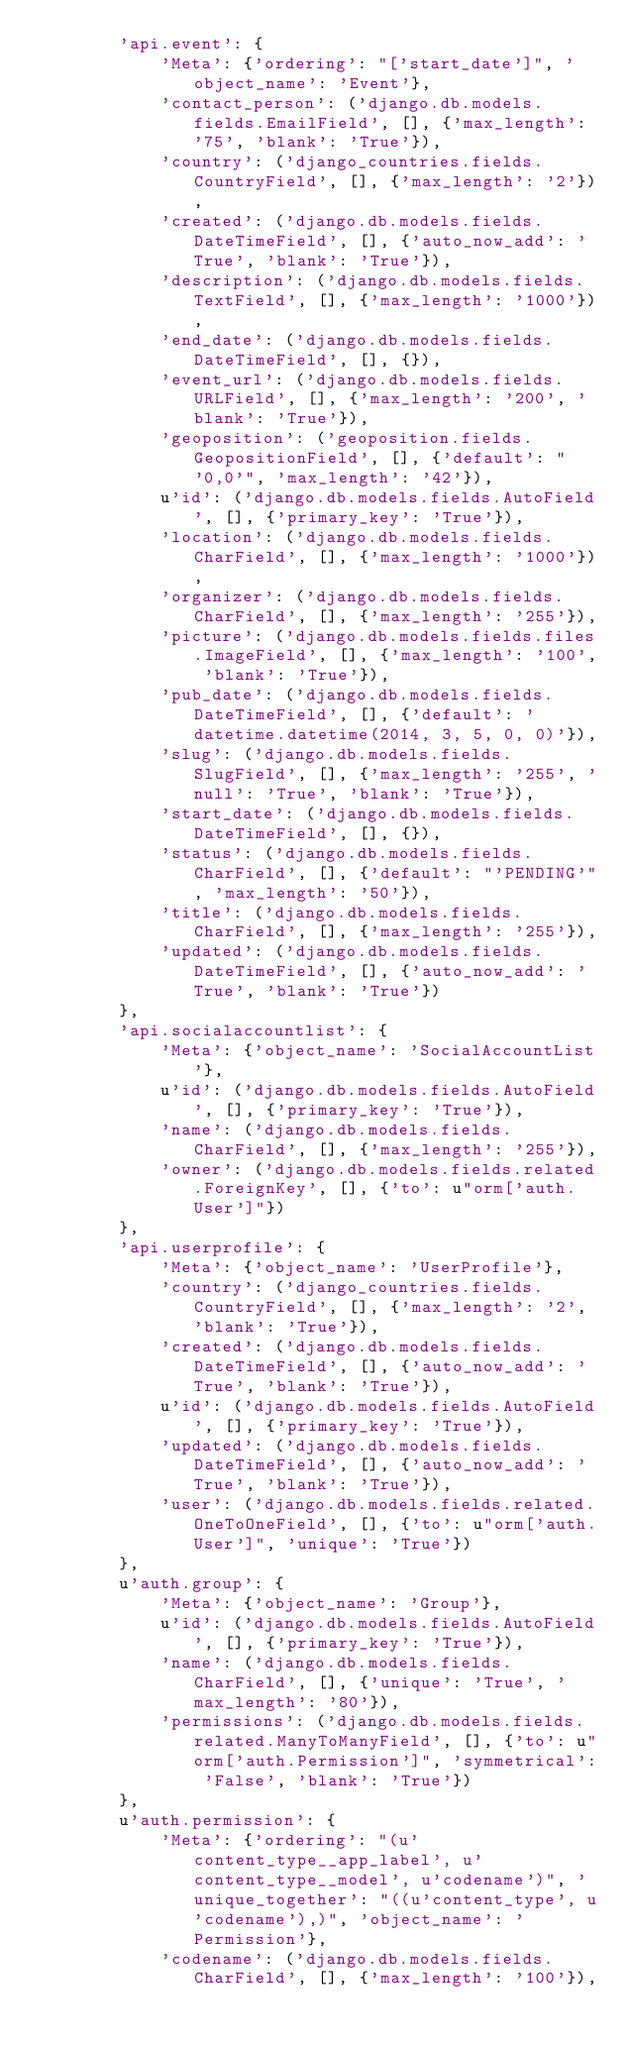<code> <loc_0><loc_0><loc_500><loc_500><_Python_>        'api.event': {
            'Meta': {'ordering': "['start_date']", 'object_name': 'Event'},
            'contact_person': ('django.db.models.fields.EmailField', [], {'max_length': '75', 'blank': 'True'}),
            'country': ('django_countries.fields.CountryField', [], {'max_length': '2'}),
            'created': ('django.db.models.fields.DateTimeField', [], {'auto_now_add': 'True', 'blank': 'True'}),
            'description': ('django.db.models.fields.TextField', [], {'max_length': '1000'}),
            'end_date': ('django.db.models.fields.DateTimeField', [], {}),
            'event_url': ('django.db.models.fields.URLField', [], {'max_length': '200', 'blank': 'True'}),
            'geoposition': ('geoposition.fields.GeopositionField', [], {'default': "'0,0'", 'max_length': '42'}),
            u'id': ('django.db.models.fields.AutoField', [], {'primary_key': 'True'}),
            'location': ('django.db.models.fields.CharField', [], {'max_length': '1000'}),
            'organizer': ('django.db.models.fields.CharField', [], {'max_length': '255'}),
            'picture': ('django.db.models.fields.files.ImageField', [], {'max_length': '100', 'blank': 'True'}),
            'pub_date': ('django.db.models.fields.DateTimeField', [], {'default': 'datetime.datetime(2014, 3, 5, 0, 0)'}),
            'slug': ('django.db.models.fields.SlugField', [], {'max_length': '255', 'null': 'True', 'blank': 'True'}),
            'start_date': ('django.db.models.fields.DateTimeField', [], {}),
            'status': ('django.db.models.fields.CharField', [], {'default': "'PENDING'", 'max_length': '50'}),
            'title': ('django.db.models.fields.CharField', [], {'max_length': '255'}),
            'updated': ('django.db.models.fields.DateTimeField', [], {'auto_now_add': 'True', 'blank': 'True'})
        },
        'api.socialaccountlist': {
            'Meta': {'object_name': 'SocialAccountList'},
            u'id': ('django.db.models.fields.AutoField', [], {'primary_key': 'True'}),
            'name': ('django.db.models.fields.CharField', [], {'max_length': '255'}),
            'owner': ('django.db.models.fields.related.ForeignKey', [], {'to': u"orm['auth.User']"})
        },
        'api.userprofile': {
            'Meta': {'object_name': 'UserProfile'},
            'country': ('django_countries.fields.CountryField', [], {'max_length': '2', 'blank': 'True'}),
            'created': ('django.db.models.fields.DateTimeField', [], {'auto_now_add': 'True', 'blank': 'True'}),
            u'id': ('django.db.models.fields.AutoField', [], {'primary_key': 'True'}),
            'updated': ('django.db.models.fields.DateTimeField', [], {'auto_now_add': 'True', 'blank': 'True'}),
            'user': ('django.db.models.fields.related.OneToOneField', [], {'to': u"orm['auth.User']", 'unique': 'True'})
        },
        u'auth.group': {
            'Meta': {'object_name': 'Group'},
            u'id': ('django.db.models.fields.AutoField', [], {'primary_key': 'True'}),
            'name': ('django.db.models.fields.CharField', [], {'unique': 'True', 'max_length': '80'}),
            'permissions': ('django.db.models.fields.related.ManyToManyField', [], {'to': u"orm['auth.Permission']", 'symmetrical': 'False', 'blank': 'True'})
        },
        u'auth.permission': {
            'Meta': {'ordering': "(u'content_type__app_label', u'content_type__model', u'codename')", 'unique_together': "((u'content_type', u'codename'),)", 'object_name': 'Permission'},
            'codename': ('django.db.models.fields.CharField', [], {'max_length': '100'}),</code> 